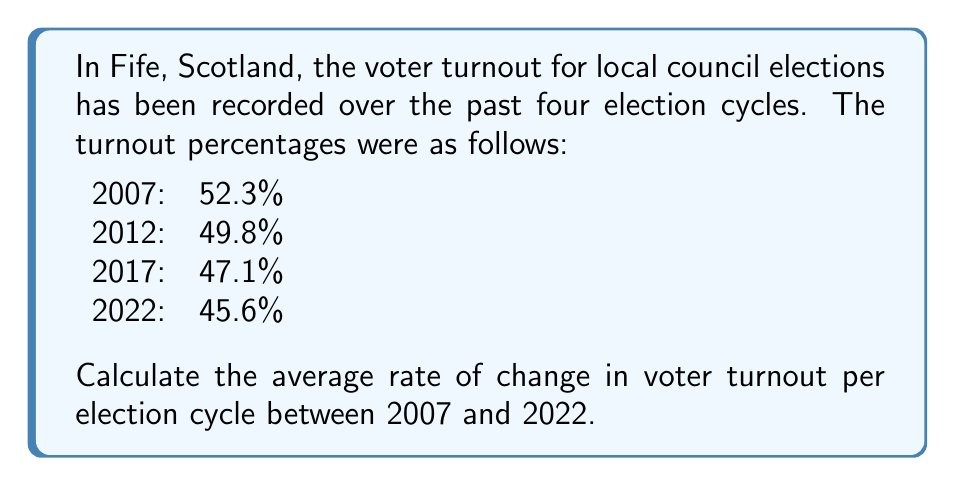Provide a solution to this math problem. To calculate the average rate of change in voter turnout, we'll follow these steps:

1. Calculate the total change in voter turnout from 2007 to 2022:
   $$\text{Total change} = 45.6\% - 52.3\% = -6.7\%$$

2. Determine the number of intervals (election cycles) between 2007 and 2022:
   $$\text{Number of intervals} = 3$$
   (2007 to 2012, 2012 to 2017, 2017 to 2022)

3. Calculate the average rate of change using the formula:
   $$\text{Average rate of change} = \frac{\text{Total change}}{\text{Number of intervals}}$$

4. Substitute the values:
   $$\text{Average rate of change} = \frac{-6.7\%}{3} = -2.23\%$$
   
5. Round to two decimal places:
   $$\text{Average rate of change} \approx -2.23\% \text{ per election cycle}$$

This negative value indicates a decreasing trend in voter turnout over the given period.
Answer: $-2.23\%$ per election cycle 